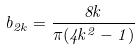<formula> <loc_0><loc_0><loc_500><loc_500>b _ { 2 k } = \frac { 8 k } { \pi ( 4 k ^ { 2 } - 1 ) }</formula> 